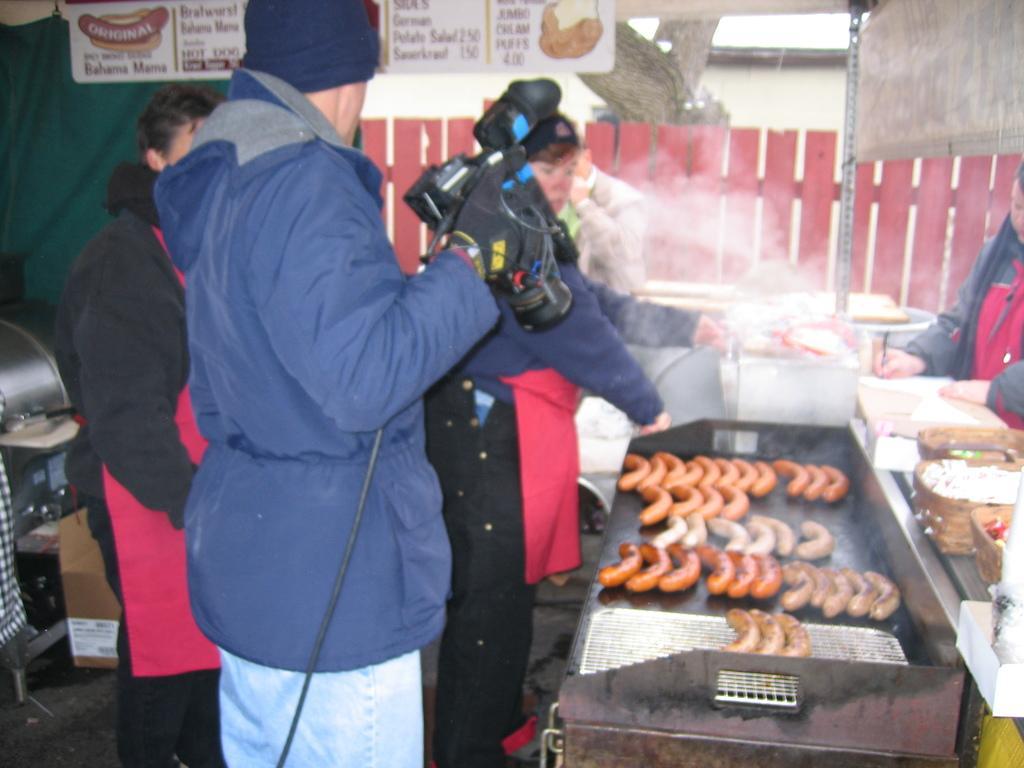How would you summarize this image in a sentence or two? This image is taken indoors. In the background there is a wooden fence. There are two boards with text on them. There is a tree and there is a wall. There is a curtain. At the bottom of the image there is a floor. In the middle of the image two women are standing on the floor and a man is standing on the floor and he is holding a camera in his hand. On the right side of the image a few people are standing. There is a table with a few things on it. There is a stove with a few sausages on it. On the left side of the image there are a few things. 